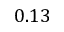<formula> <loc_0><loc_0><loc_500><loc_500>0 . 1 3</formula> 